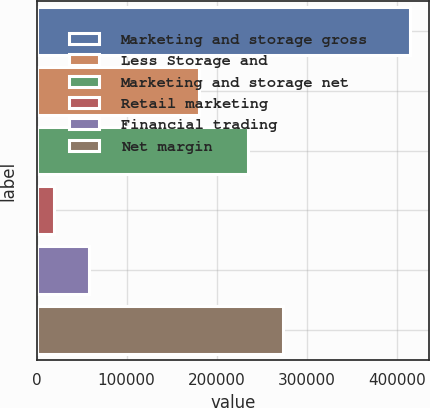<chart> <loc_0><loc_0><loc_500><loc_500><bar_chart><fcel>Marketing and storage gross<fcel>Less Storage and<fcel>Marketing and storage net<fcel>Retail marketing<fcel>Financial trading<fcel>Net margin<nl><fcel>414951<fcel>180708<fcel>234243<fcel>19006<fcel>58600.5<fcel>273838<nl></chart> 